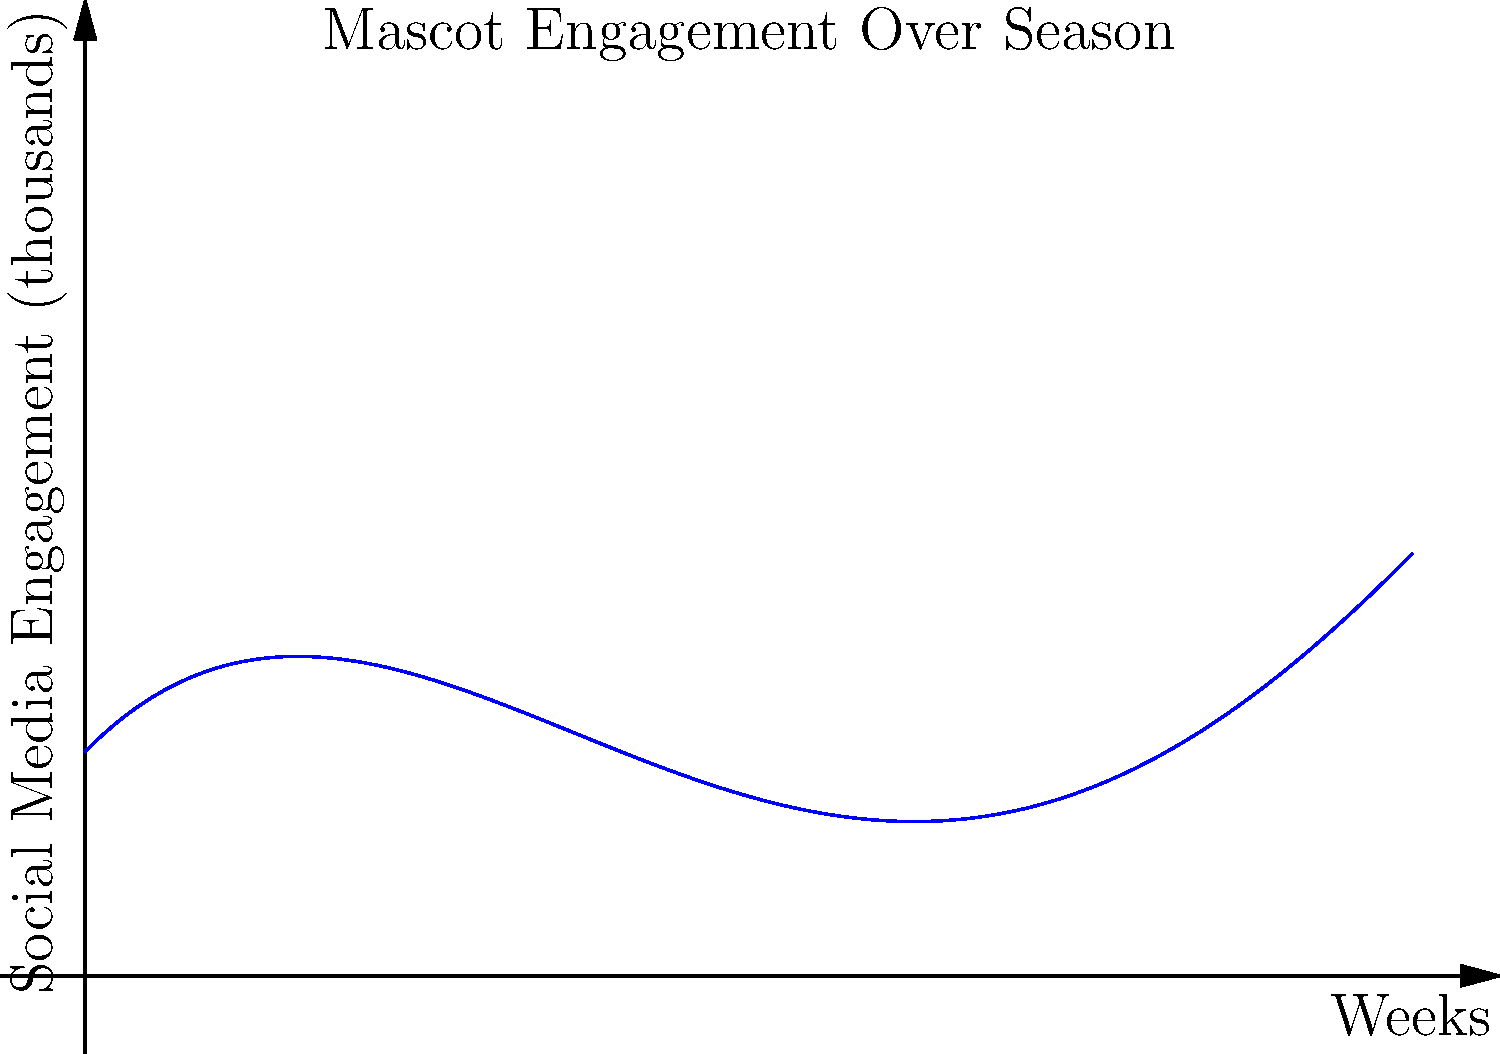The graph shows the social media engagement (in thousands) of a beloved university mascot over an 8-week football season. Find the inflection points of this function, which represent the weeks when the rate of change in engagement shifted most dramatically. To find the inflection points, we need to follow these steps:

1) The function appears to be a 4th-degree polynomial. Let's assume it has the form:
   $f(x) = -0.005x^4 + 0.12x^3 - 0.8x^2 + 1.5x + 2$

2) To find inflection points, we need to find where the second derivative equals zero.

3) First derivative:
   $f'(x) = -0.02x^3 + 0.36x^2 - 1.6x + 1.5$

4) Second derivative:
   $f''(x) = -0.06x^2 + 0.72x - 1.6$

5) Set $f''(x) = 0$ and solve:
   $-0.06x^2 + 0.72x - 1.6 = 0$

6) This is a quadratic equation. We can solve it using the quadratic formula:
   $x = \frac{-b \pm \sqrt{b^2 - 4ac}}{2a}$

   Where $a = -0.06$, $b = 0.72$, and $c = -1.6$

7) Plugging in these values:
   $x = \frac{-0.72 \pm \sqrt{0.72^2 - 4(-0.06)(-1.6)}}{2(-0.06)}$

8) Simplifying:
   $x = \frac{-0.72 \pm \sqrt{0.5184 + 0.384}}{-0.12} = \frac{-0.72 \pm \sqrt{0.9024}}{-0.12}$

9) Solving:
   $x \approx 2$ or $x \approx 6$

Therefore, the inflection points occur at approximately week 2 and week 6 of the season.
Answer: Week 2 and Week 6 